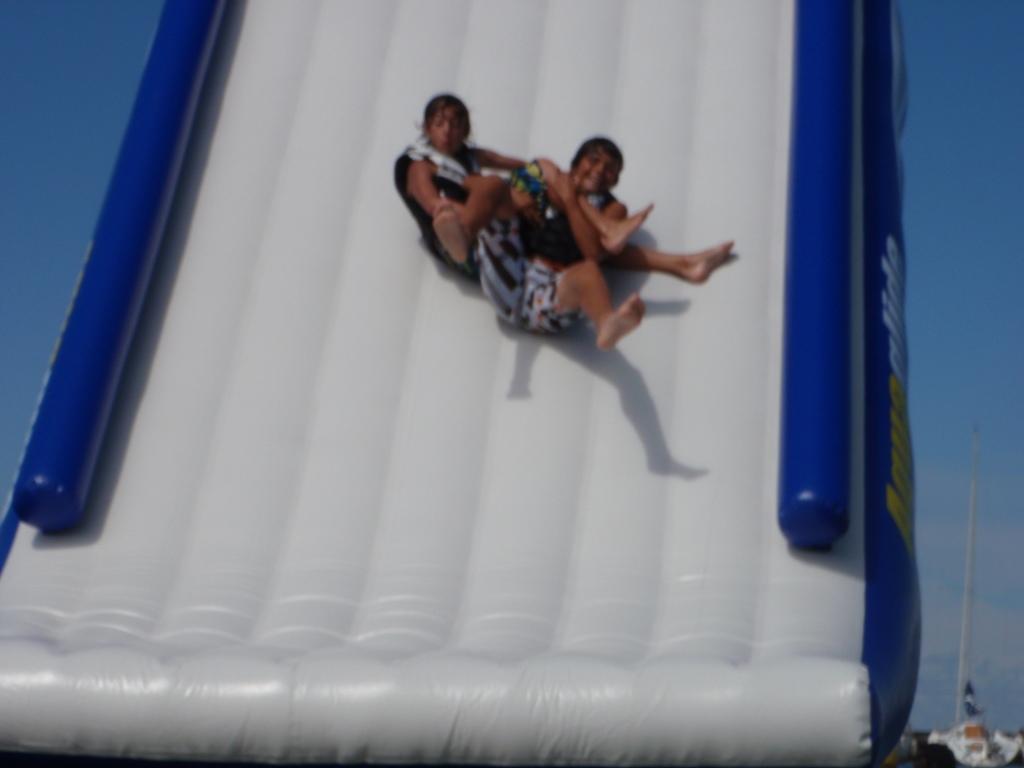Can you describe this image briefly? In this image we can see the two persons sliding on an object. There is a clear and blue sky in the image. 